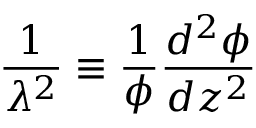<formula> <loc_0><loc_0><loc_500><loc_500>{ \frac { 1 } { \lambda ^ { 2 } } } \equiv \frac { 1 } { \phi } { \frac { d ^ { 2 } \phi } { d z ^ { 2 } } }</formula> 